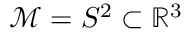<formula> <loc_0><loc_0><loc_500><loc_500>\mathcal { M } = S ^ { 2 } \subset \mathbb { R } ^ { 3 }</formula> 